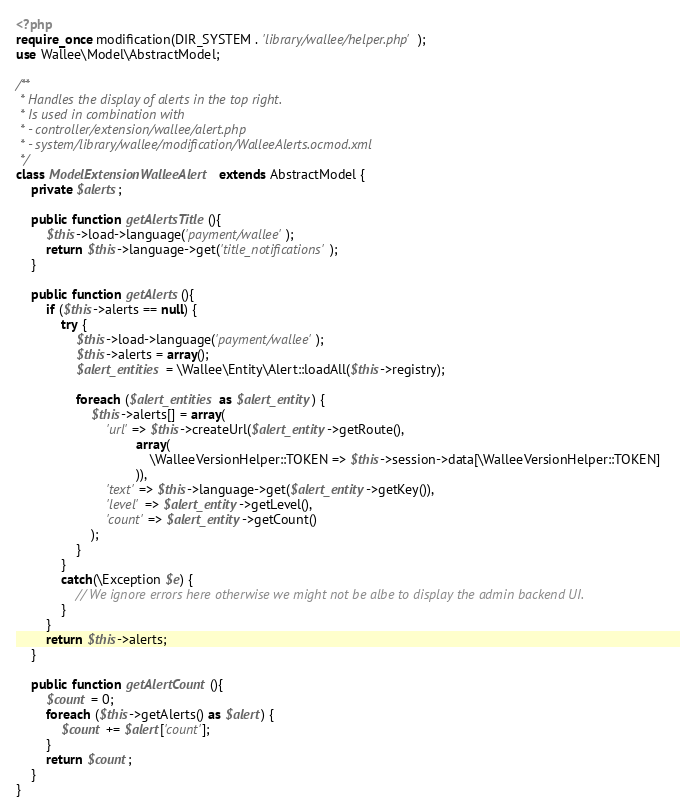<code> <loc_0><loc_0><loc_500><loc_500><_PHP_><?php
require_once modification(DIR_SYSTEM . 'library/wallee/helper.php');
use Wallee\Model\AbstractModel;

/**
 * Handles the display of alerts in the top right.
 * Is used in combination with
 * - controller/extension/wallee/alert.php
 * - system/library/wallee/modification/WalleeAlerts.ocmod.xml
 */
class ModelExtensionWalleeAlert extends AbstractModel {
	private $alerts;

	public function getAlertsTitle(){
		$this->load->language('payment/wallee');
		return $this->language->get('title_notifications');
	}

	public function getAlerts(){
		if ($this->alerts == null) {
			try {
				$this->load->language('payment/wallee');
				$this->alerts = array();
				$alert_entities = \Wallee\Entity\Alert::loadAll($this->registry);
			
				foreach ($alert_entities as $alert_entity) {
					$this->alerts[] = array(
						'url' => $this->createUrl($alert_entity->getRoute(),
								array(
									\WalleeVersionHelper::TOKEN => $this->session->data[\WalleeVersionHelper::TOKEN] 
								)),
						'text' => $this->language->get($alert_entity->getKey()),
						'level' => $alert_entity->getLevel(),
						'count' => $alert_entity->getCount() 
					);
				}
			}
			catch(\Exception $e) {
				// We ignore errors here otherwise we might not be albe to display the admin backend UI.
			}
		}
		return $this->alerts;
	}

	public function getAlertCount(){
		$count = 0;
		foreach ($this->getAlerts() as $alert) {
			$count += $alert['count'];
		}
		return $count;
	}
}
</code> 